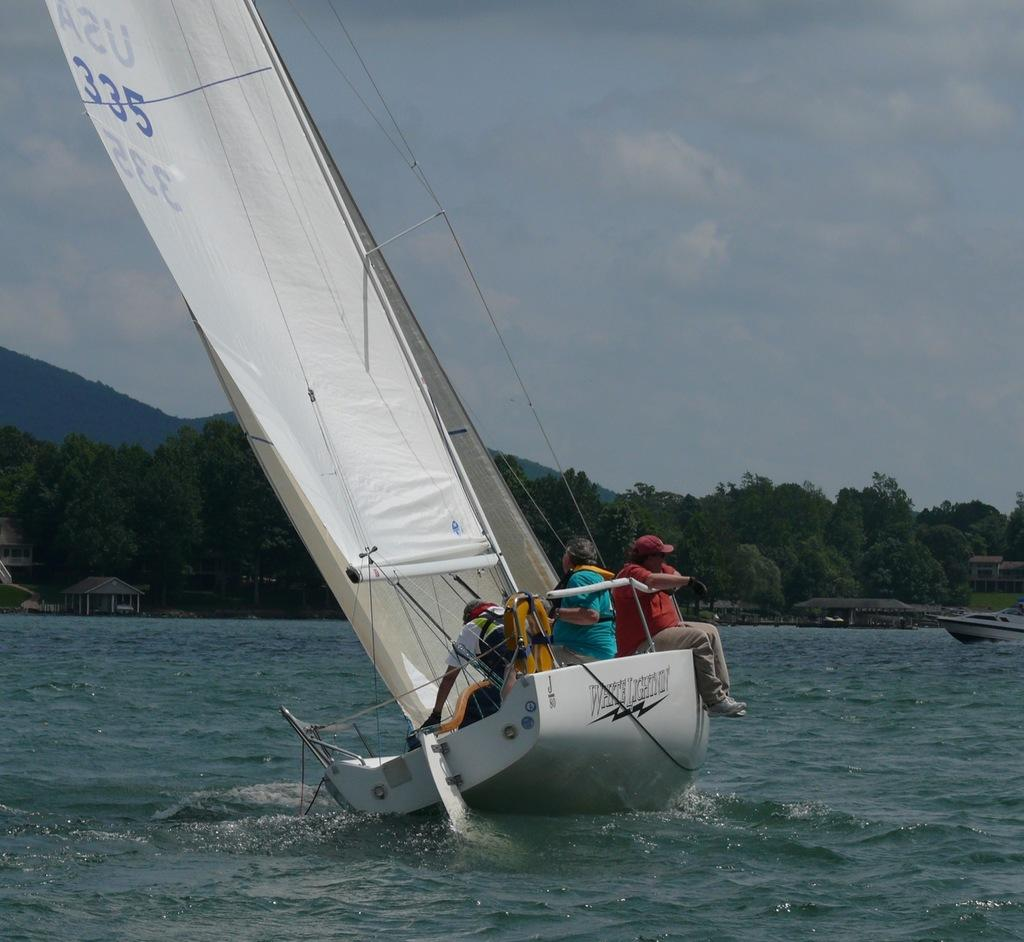What is the main subject of the image? The main subject of the image is a white-colored boat. Are there any people in the boat? Yes, there are people sitting in the boat. What is visible at the bottom of the image? The bottom of the image contains the sea. What type of vegetation can be seen at the back side of the image? There are trees at the back side of the image. What is visible at the top of the image? The sky is visible at the top of the image. What type of trade is happening between the bees and the boat in the image? There are no bees present in the image, and therefore no trade can be observed. 